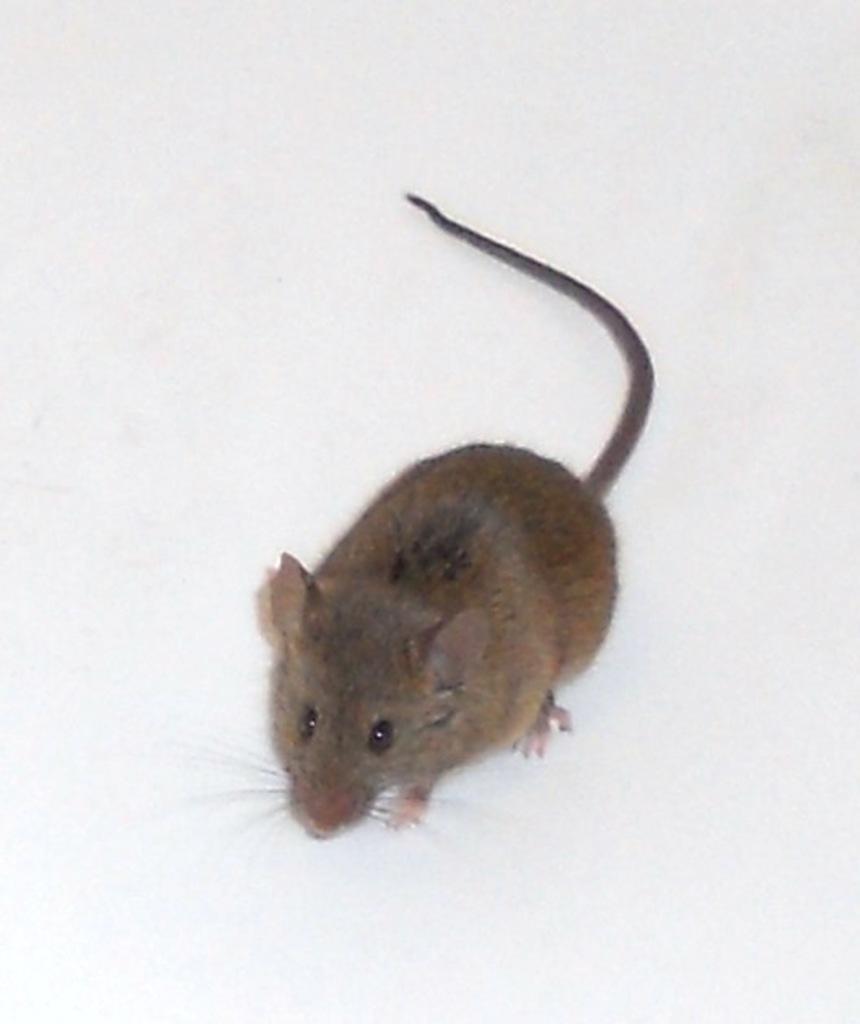Please provide a concise description of this image. In the center of the picture we can see a rat on a white surface. 